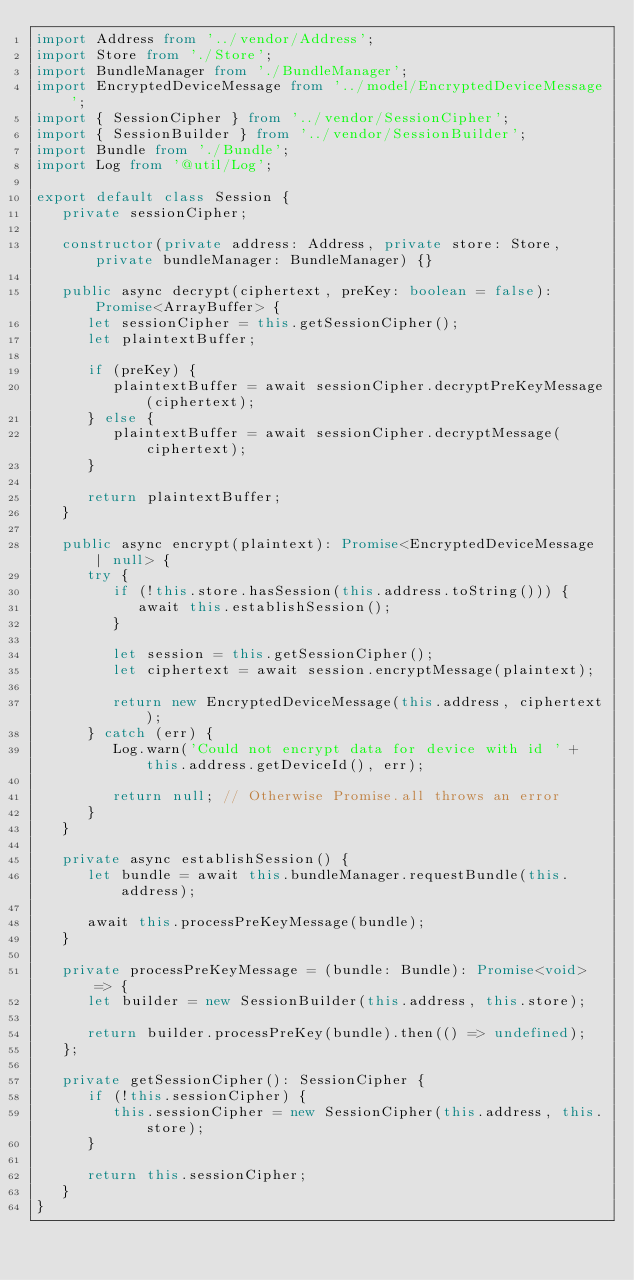Convert code to text. <code><loc_0><loc_0><loc_500><loc_500><_TypeScript_>import Address from '../vendor/Address';
import Store from './Store';
import BundleManager from './BundleManager';
import EncryptedDeviceMessage from '../model/EncryptedDeviceMessage';
import { SessionCipher } from '../vendor/SessionCipher';
import { SessionBuilder } from '../vendor/SessionBuilder';
import Bundle from './Bundle';
import Log from '@util/Log';

export default class Session {
   private sessionCipher;

   constructor(private address: Address, private store: Store, private bundleManager: BundleManager) {}

   public async decrypt(ciphertext, preKey: boolean = false): Promise<ArrayBuffer> {
      let sessionCipher = this.getSessionCipher();
      let plaintextBuffer;

      if (preKey) {
         plaintextBuffer = await sessionCipher.decryptPreKeyMessage(ciphertext);
      } else {
         plaintextBuffer = await sessionCipher.decryptMessage(ciphertext);
      }

      return plaintextBuffer;
   }

   public async encrypt(plaintext): Promise<EncryptedDeviceMessage | null> {
      try {
         if (!this.store.hasSession(this.address.toString())) {
            await this.establishSession();
         }

         let session = this.getSessionCipher();
         let ciphertext = await session.encryptMessage(plaintext);

         return new EncryptedDeviceMessage(this.address, ciphertext);
      } catch (err) {
         Log.warn('Could not encrypt data for device with id ' + this.address.getDeviceId(), err);

         return null; // Otherwise Promise.all throws an error
      }
   }

   private async establishSession() {
      let bundle = await this.bundleManager.requestBundle(this.address);

      await this.processPreKeyMessage(bundle);
   }

   private processPreKeyMessage = (bundle: Bundle): Promise<void> => {
      let builder = new SessionBuilder(this.address, this.store);

      return builder.processPreKey(bundle).then(() => undefined);
   };

   private getSessionCipher(): SessionCipher {
      if (!this.sessionCipher) {
         this.sessionCipher = new SessionCipher(this.address, this.store);
      }

      return this.sessionCipher;
   }
}
</code> 